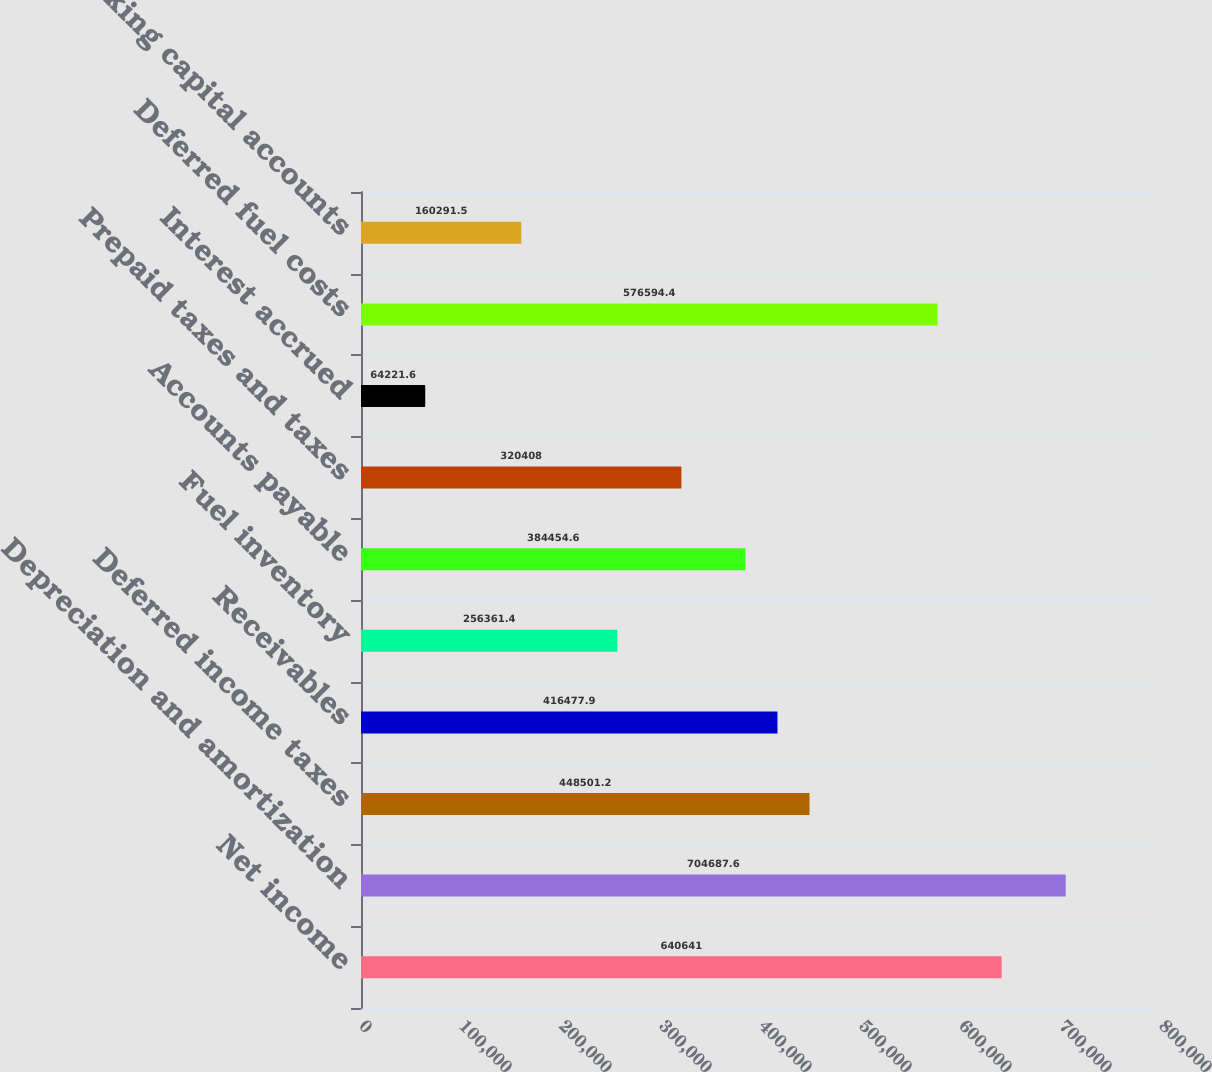Convert chart. <chart><loc_0><loc_0><loc_500><loc_500><bar_chart><fcel>Net income<fcel>Depreciation and amortization<fcel>Deferred income taxes<fcel>Receivables<fcel>Fuel inventory<fcel>Accounts payable<fcel>Prepaid taxes and taxes<fcel>Interest accrued<fcel>Deferred fuel costs<fcel>Other working capital accounts<nl><fcel>640641<fcel>704688<fcel>448501<fcel>416478<fcel>256361<fcel>384455<fcel>320408<fcel>64221.6<fcel>576594<fcel>160292<nl></chart> 